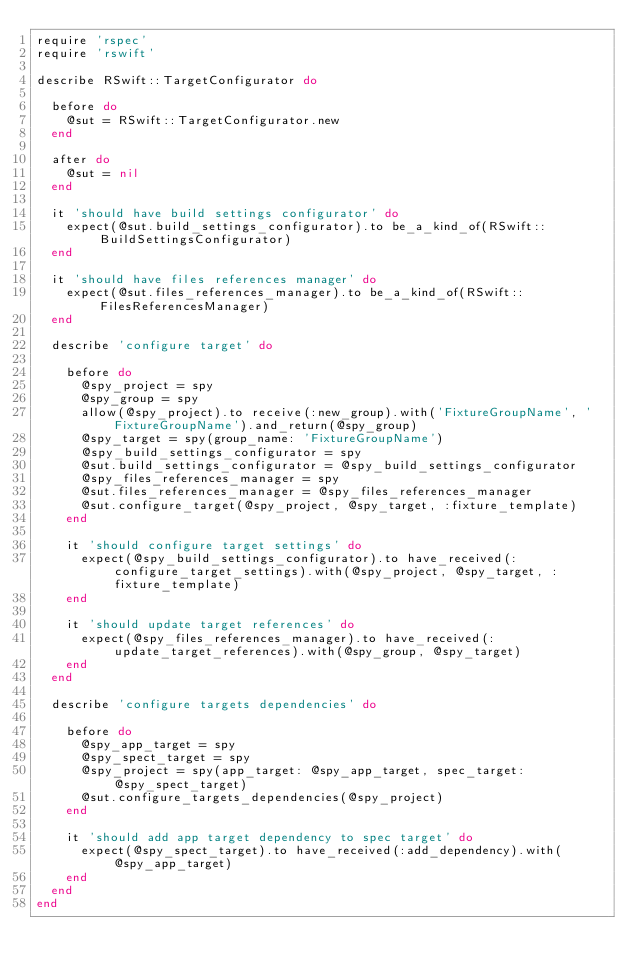<code> <loc_0><loc_0><loc_500><loc_500><_Ruby_>require 'rspec'
require 'rswift'

describe RSwift::TargetConfigurator do

  before do
    @sut = RSwift::TargetConfigurator.new
  end

  after do
    @sut = nil
  end

  it 'should have build settings configurator' do
    expect(@sut.build_settings_configurator).to be_a_kind_of(RSwift::BuildSettingsConfigurator)
  end

  it 'should have files references manager' do
    expect(@sut.files_references_manager).to be_a_kind_of(RSwift::FilesReferencesManager)
  end

  describe 'configure target' do

    before do
      @spy_project = spy
      @spy_group = spy
      allow(@spy_project).to receive(:new_group).with('FixtureGroupName', 'FixtureGroupName').and_return(@spy_group)
      @spy_target = spy(group_name: 'FixtureGroupName')
      @spy_build_settings_configurator = spy
      @sut.build_settings_configurator = @spy_build_settings_configurator
      @spy_files_references_manager = spy
      @sut.files_references_manager = @spy_files_references_manager
      @sut.configure_target(@spy_project, @spy_target, :fixture_template)
    end

    it 'should configure target settings' do
      expect(@spy_build_settings_configurator).to have_received(:configure_target_settings).with(@spy_project, @spy_target, :fixture_template)
    end

    it 'should update target references' do
      expect(@spy_files_references_manager).to have_received(:update_target_references).with(@spy_group, @spy_target)
    end
  end

  describe 'configure targets dependencies' do

    before do
      @spy_app_target = spy
      @spy_spect_target = spy
      @spy_project = spy(app_target: @spy_app_target, spec_target: @spy_spect_target)
      @sut.configure_targets_dependencies(@spy_project)
    end

    it 'should add app target dependency to spec target' do
      expect(@spy_spect_target).to have_received(:add_dependency).with(@spy_app_target)
    end
  end
end
</code> 